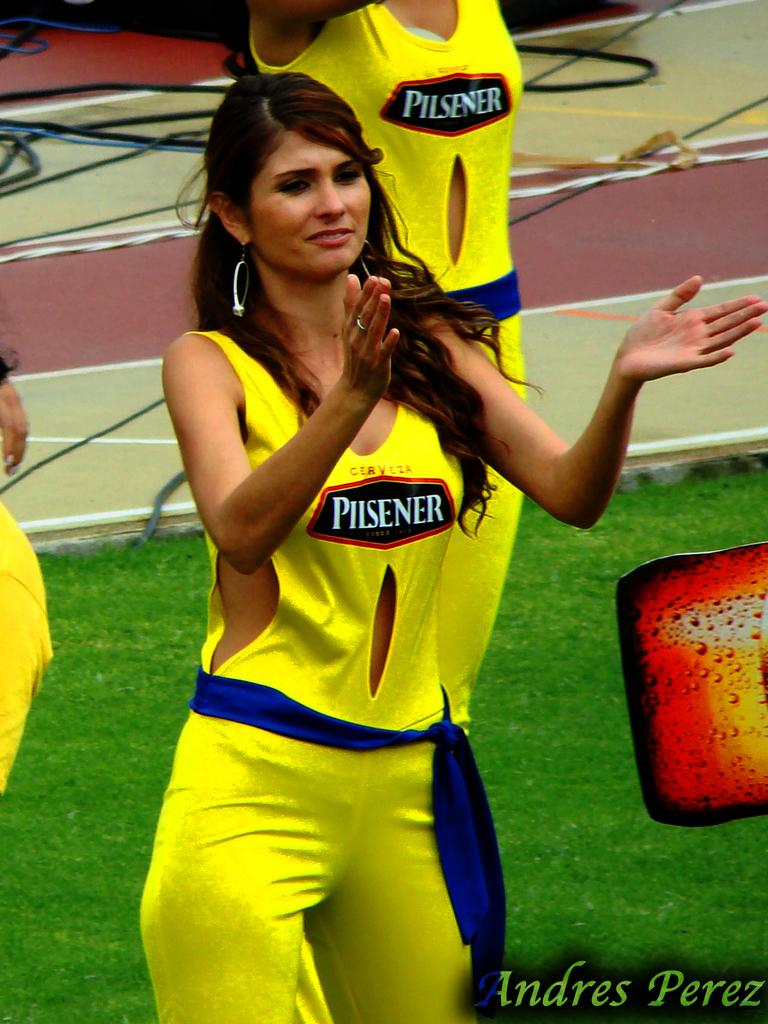Provide a one-sentence caption for the provided image. A woman in a yellow shirt that says Pilsener is standing on a field. 